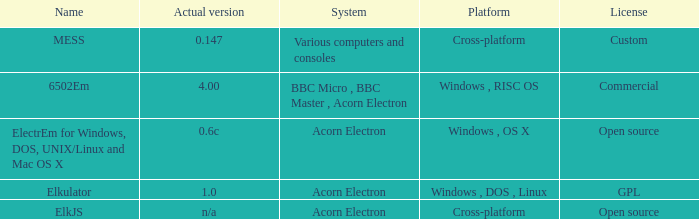Which framework is known as elkjs? Acorn Electron. 